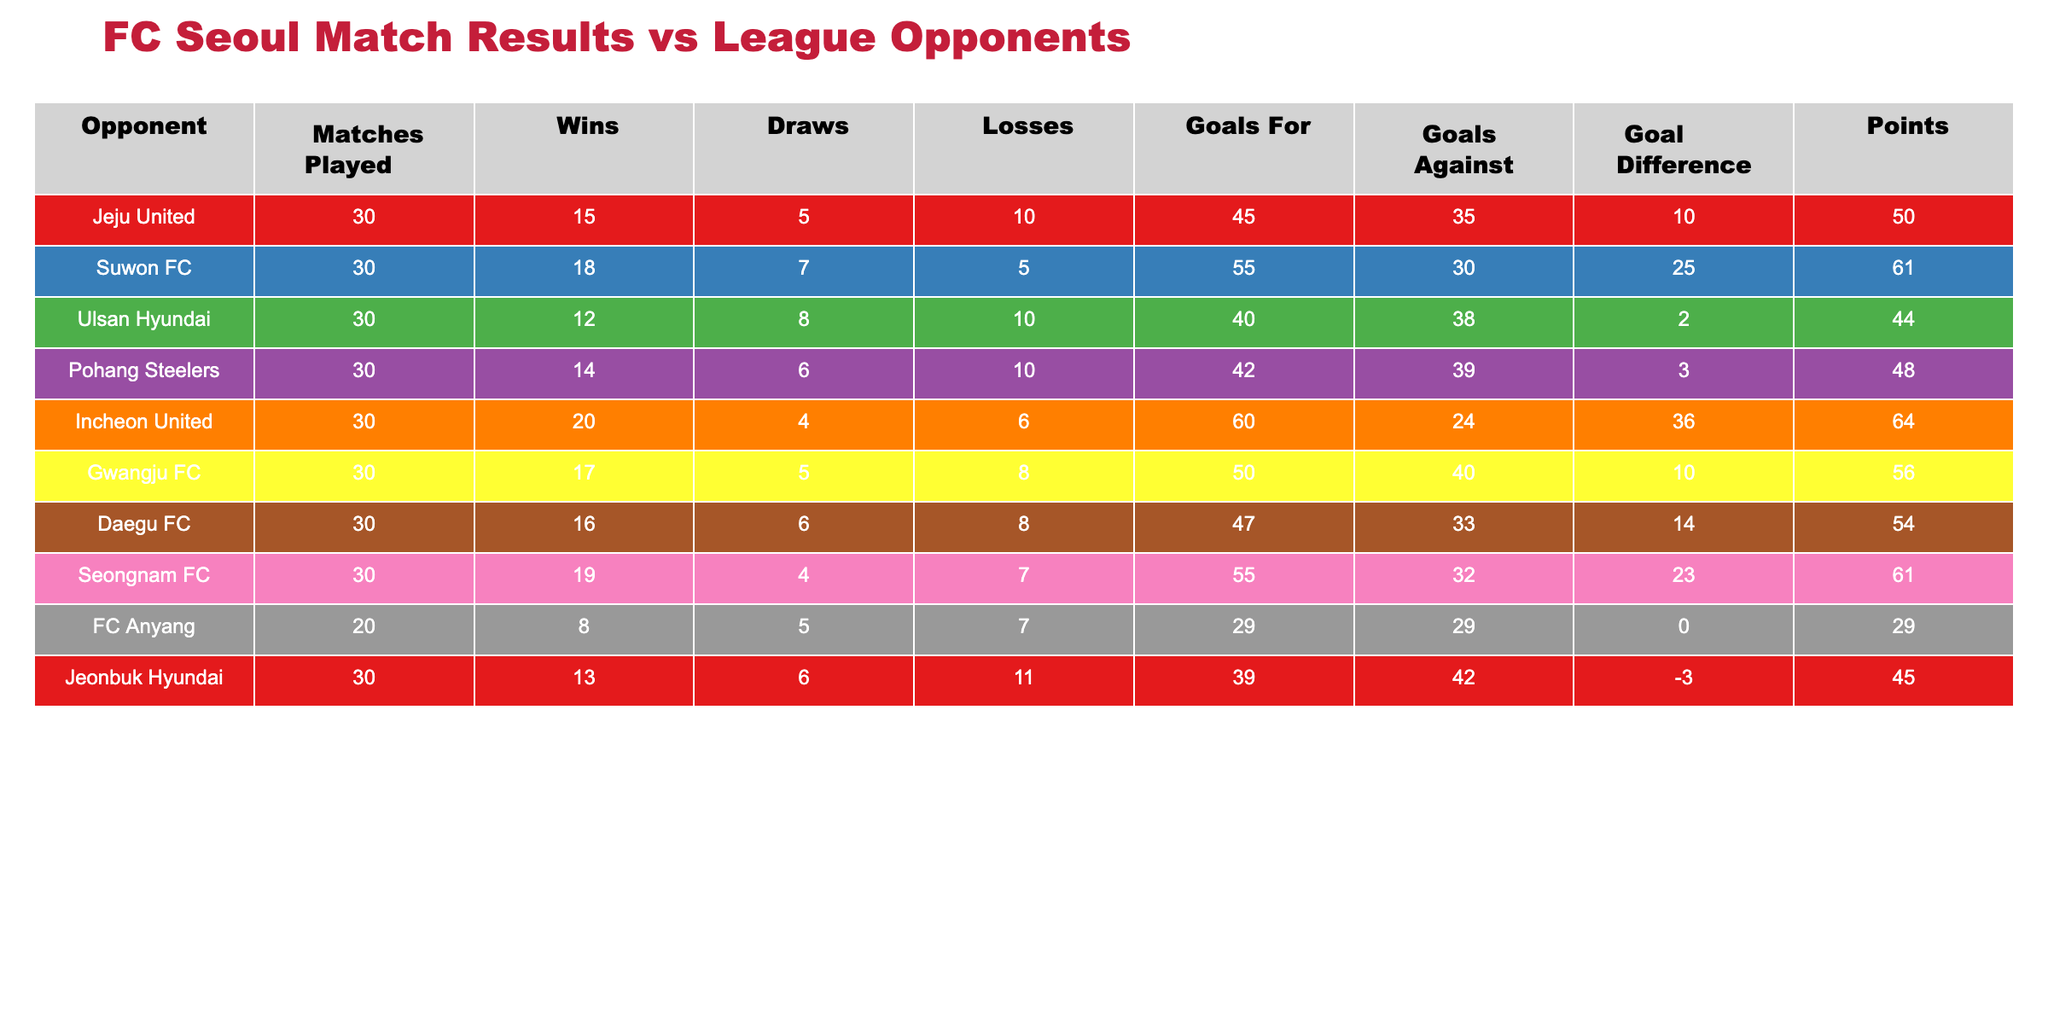What is the total number of matches played by FC Seoul against all opponents? To find the total number of matches played, we add up the "Matches Played" column for all opponents: 30 + 30 + 30 + 30 + 30 + 30 + 30 + 30 + 20 + 30 = 290.
Answer: 290 Which opponent did FC Seoul score the most goals against? By examining the "Goals For" column, we see the highest number is 60 against Incheon United.
Answer: Incheon United What is the goal difference for FC Seoul when playing against Jeju United? The goal difference is calculated by subtracting "Goals Against" from "Goals For" for Jeju United: 45 - 35 = 10.
Answer: +10 Did FC Seoul win more matches against Gwangju FC or Daegu FC? FC Seoul won 17 matches against Gwangju FC and 16 matches against Daegu FC. Since 17 is greater than 16, FC Seoul won more against Gwangju FC.
Answer: Yes What is the average points earned by FC Seoul against the league opponents? We sum the points for all opponents: 50 + 61 + 44 + 48 + 64 + 56 + 54 + 61 + 29 + 45 = 458. There are 10 opponents, so the average is 458 / 10 = 45.8.
Answer: 45.8 Which opponent had the highest number of losses against FC Seoul? Looking at the "Losses" column, Suwon FC had the fewest losses at 5, while Jeonbuk Hyundai had the most at 11.
Answer: Jeonbuk Hyundai What is the goal difference against Seongnam FC? The goal difference is found by subtracting "Goals Against" from "Goals For" for Seongnam FC: 55 - 32 = 23.
Answer: +23 Did FC Seoul have a negative goal difference against any opponents? Yes, the goal difference against Jeonbuk Hyundai was -3, indicating they conceded more goals than they scored in matches against them.
Answer: Yes 